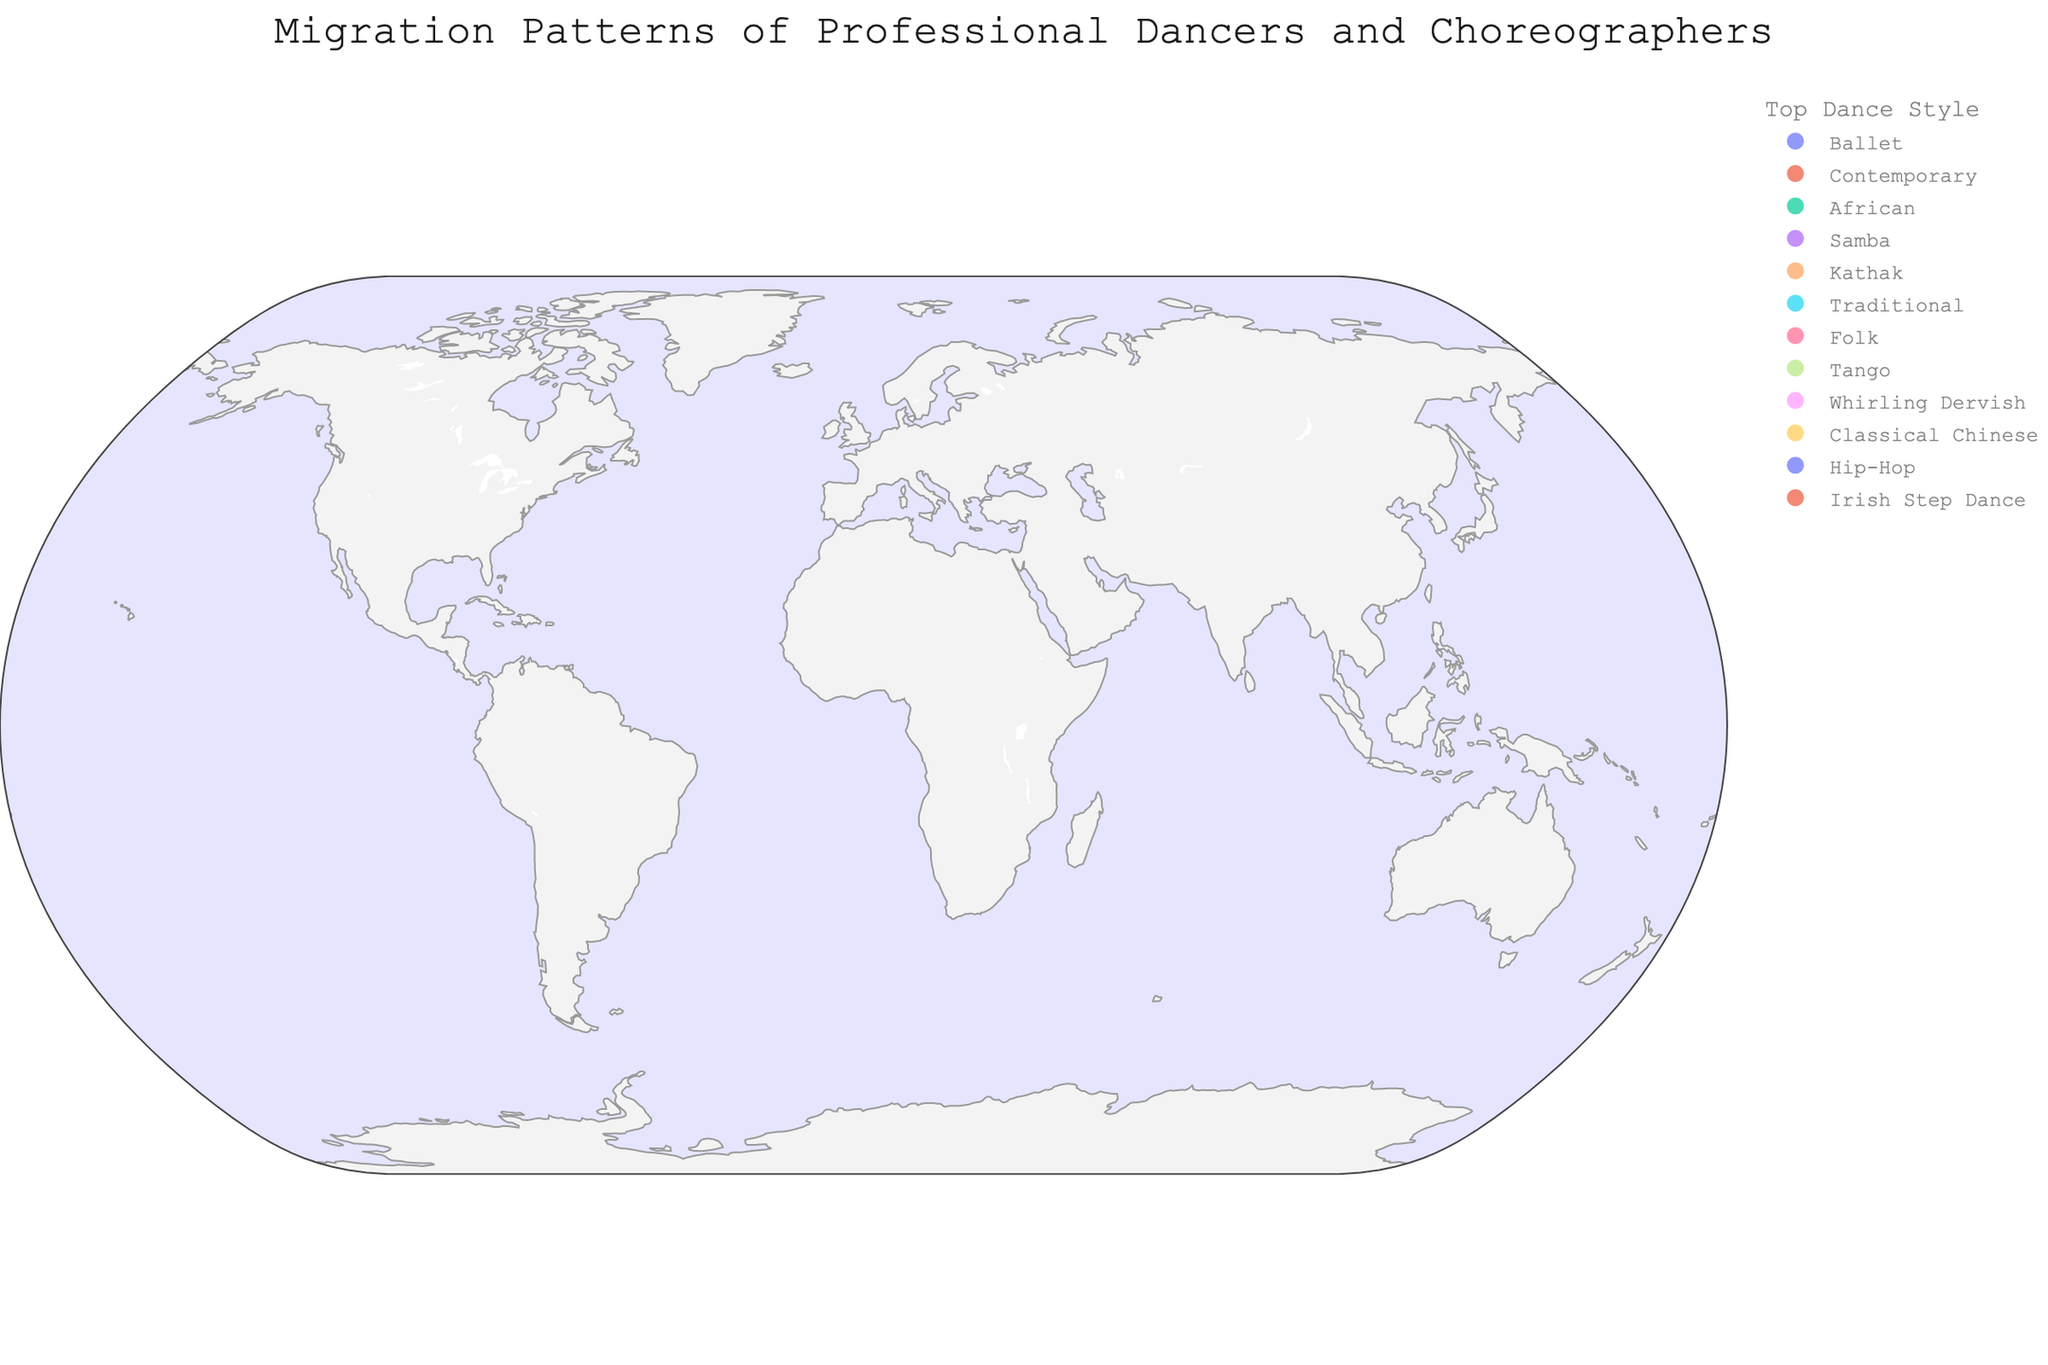How many dancers originate from Russia? Locate Russia on the map, hover over it to see the number of dancers in the tooltip. The number should be easily visible.
Answer: 150 What is the most common dance style among the migrants? Look at the legend that shows different dance styles and determines which style appears most frequently among the data points. The color coding of the legends will help you count the occurrences of each dance style.
Answer: Ballet Which country has the fewest number of dancers migrating? Observe the sizes of the circles on the map and compare to find the smallest one. Then, hover over the smallest circle to get the number of dancers and the origin country.
Answer: Ireland Compare the number of dancers migrating from Brazil and China. Which country has more? Hover over Brazil and China on the map to gather the numbers of dancers for each. Then, compare the two to see which is greater.
Answer: Brazil Calculate the total number of dancers migrating from Asian countries. Identify all Asian countries on the map (China, India, Philippines, etc.). Sum up the numbers of dancers from these countries. Detailed summing: (70 + 65 + 45) = 180.
Answer: 180 How is the color associated with the "Tango" dance style represented on the legend? Look at the legend to find the color associated with "Tango" and describe that color.
Answer: Symbol for Tango Which dance style is more common: African or Samba? Hover over the data points to see the dance styles for each country. Count how many times "African" and "Samba'' appear. Compare their frequencies.
Answer: Samba Identify the country with the maximum number of dancers migrating to the United States. Hover over the circles marked for different countries and check the one for the US. Identify the country shown for the highest number of migrants.
Answer: Russia What is the combined number of dancers migrating from countries in Europe? Identify all European countries on the map (Russia, Ukraine, Ireland, etc.). Sum up the numbers of dancers from these countries. Detailed summing: (150 + 85 + 30) = 265.
Answer: 265 Describe the migration pattern for Kathak dancers. Hover over the relevant country (India) and observe its migration flow. Describe the origin country and the destination (Japan).
Answer: From India to Japan 